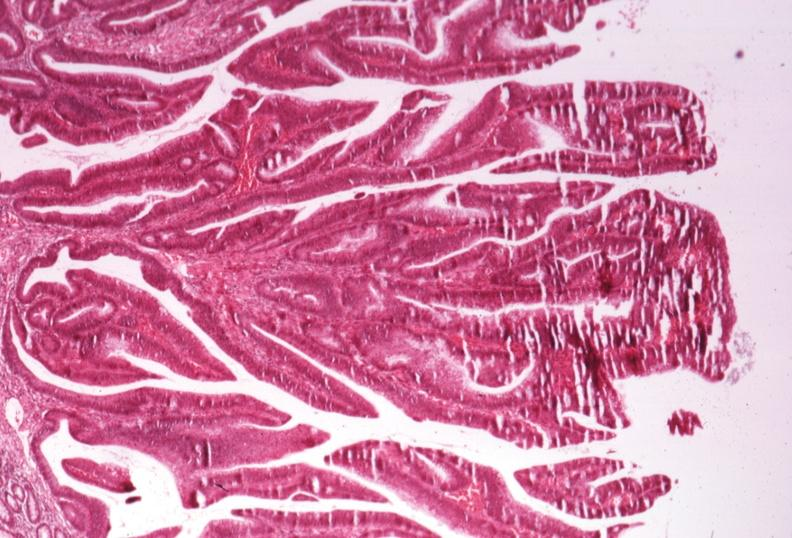s beckwith-wiedemann syndrome present?
Answer the question using a single word or phrase. No 